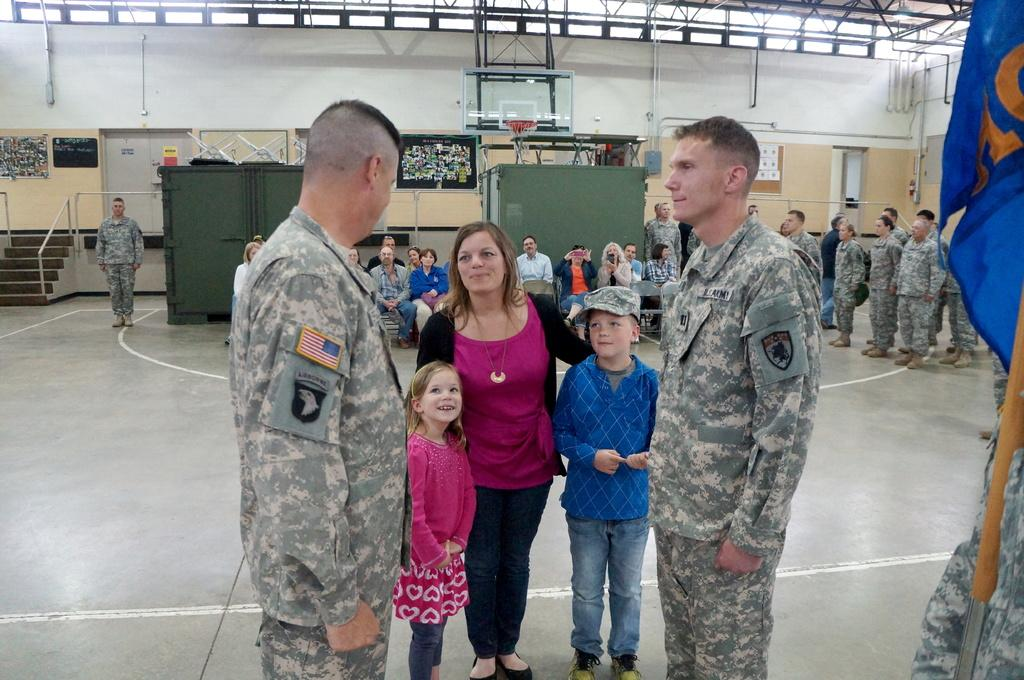How many people are in the group in the image? There is a group of people in the image, but the exact number is not specified. What are some of the people in the group doing? Some people in the group are sitting, while others are standing. What can be seen in the background of the image? There is a wall visible in the background of the image. What type of button is being pushed by one of the people in the image? There is no button present in the image; it features a group of people with some sitting and others standing. What journey are the people in the image regretting? There is no indication in the image that the people are regretting any journey or decision. 